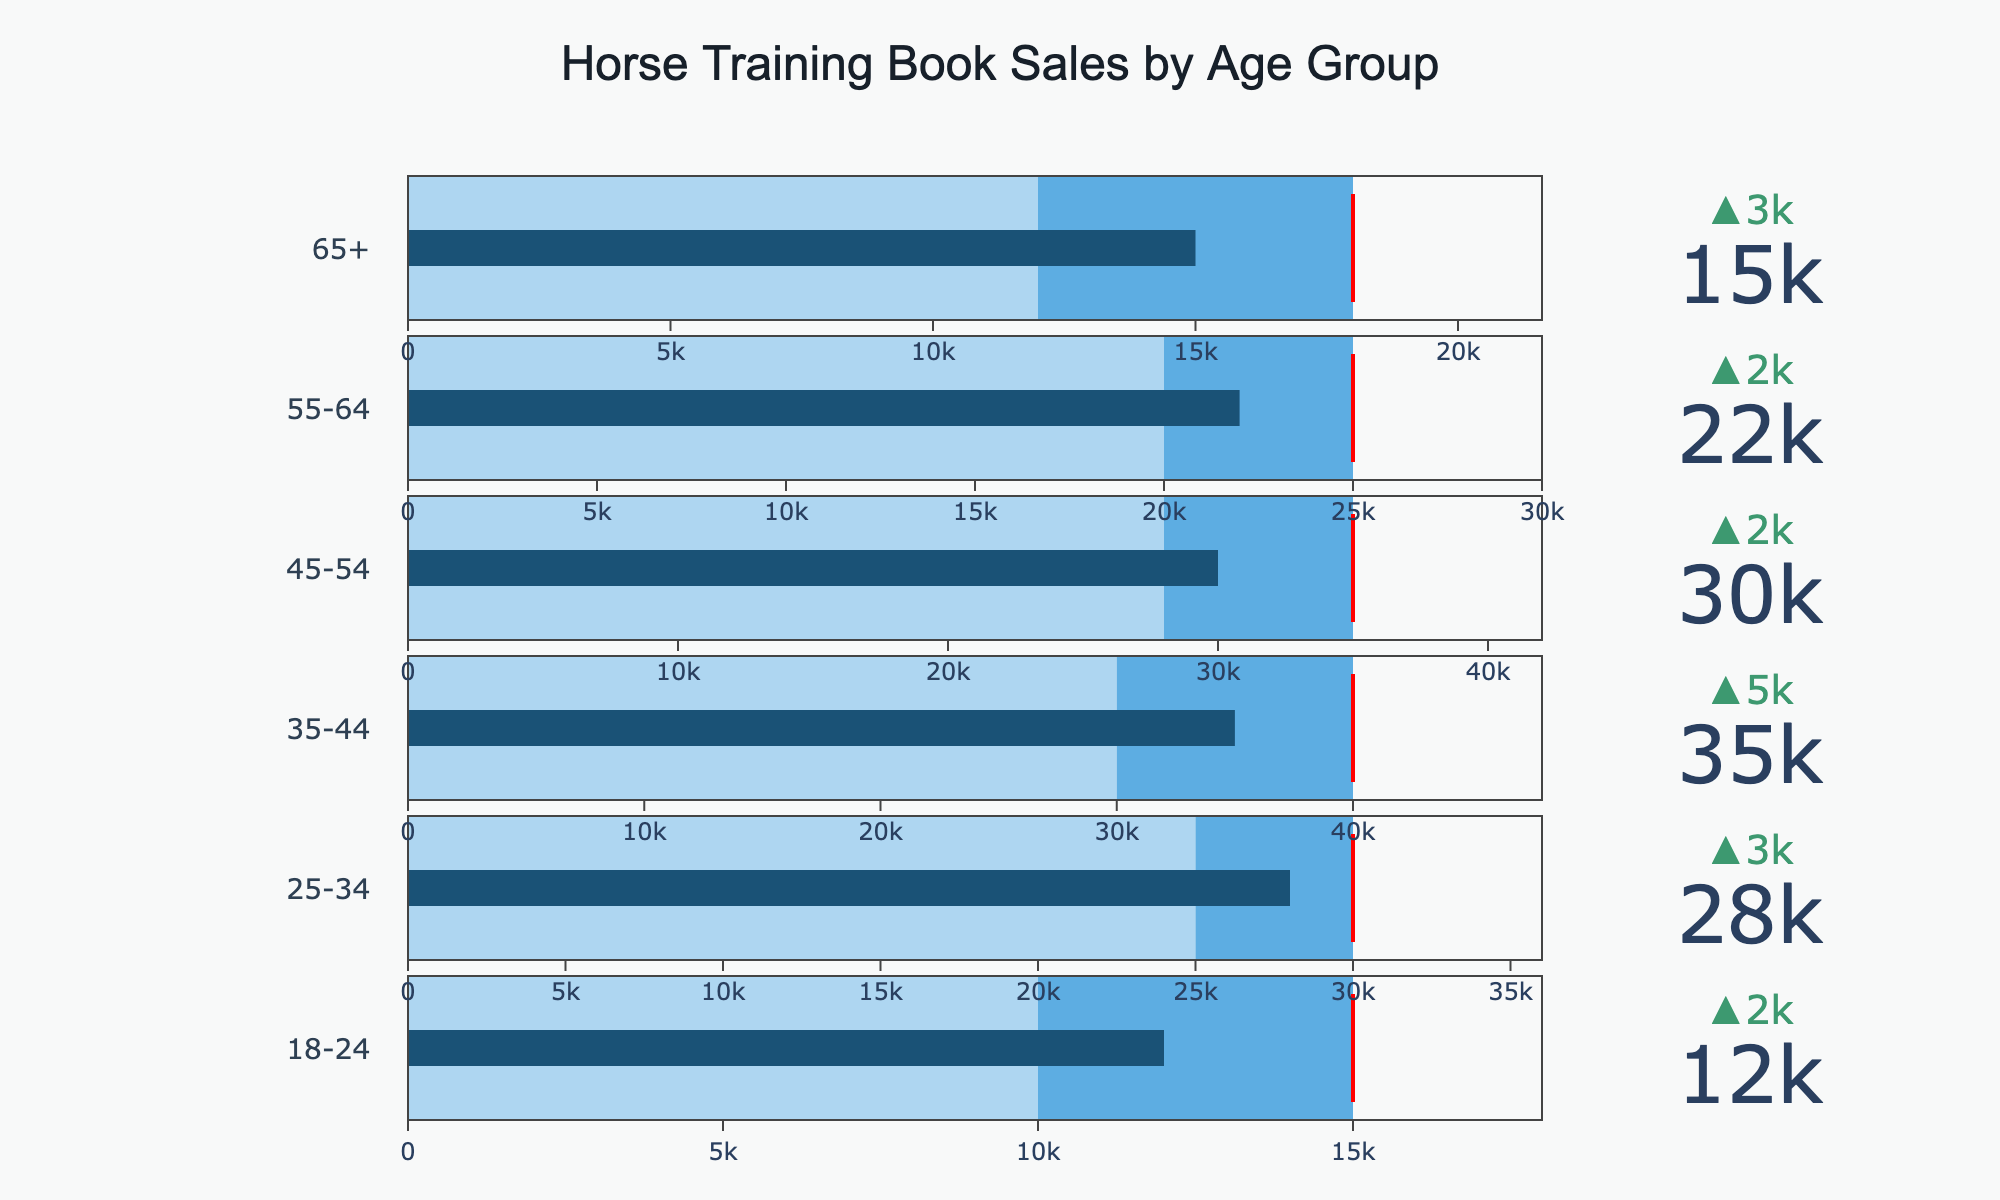What is the title of the chart? The title is displayed at the top of the chart, centered and in a larger font size, indicating the overall topic of the data being presented.
Answer: Horse Training Book Sales by Age Group How many age categories are represented in the bullet chart? The chart has rows, each corresponding to a different age group, which can be counted to determine the number of categories.
Answer: 6 Which age group has the highest actual book sales? By examining the value for the "Actual" sales in each age group's bullet chart, you can identify the highest value.
Answer: 35-44 How does the actual sales for the 25-34 age group compare to the genre average? The bullet chart for the 25-34 age group shows two key values: the actual sales and the comparative (genre average) sales. Compare these two values to answer.
Answer: 3000 higher What is the target sales value for the 45-54 age group? The target value is indicated by a threshold line in the bullet chart for the 45-54 age group.
Answer: 35000 Which age group is closest to meeting its target sales? Determine how close each age group's actual sales value is to its target sales value by examining the positions of the bars relative to the threshold lines.
Answer: 25-34 Calculate the average actual sales across all age groups. Add the actual sales values for all age groups and divide by the number of age groups (6). (12000 + 28000 + 35000 + 30000 + 22000 + 15000) / 6 = 23416.67.
Answer: 23416.67 What percentage of the target sales has the 18-24 age group achieved? Divide the actual sales by the target sales for the 18-24 age group, then multiply by 100 to get the percentage. (12000 / 15000) * 100 = 80%.
Answer: 80% Compare the actual sales values for the 55-64 and 65+ age groups. Examine the actual sales bars for the 55-64 and 65+ age groups and compare the values.
Answer: 7000 higher for 55-64 Is the bullet chart for the 35-44 age group above or below the target value? Look at the bullet chart for the 35-44 age group and see whether the actual sales bar extends to or beyond the target line.
Answer: Below 